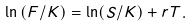<formula> <loc_0><loc_0><loc_500><loc_500>\ln \left ( F / K \right ) = \ln ( S / K ) + r T .</formula> 